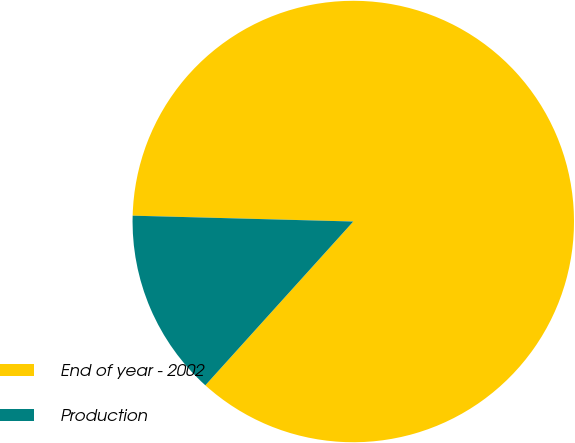Convert chart. <chart><loc_0><loc_0><loc_500><loc_500><pie_chart><fcel>End of year - 2002<fcel>Production<nl><fcel>86.27%<fcel>13.73%<nl></chart> 